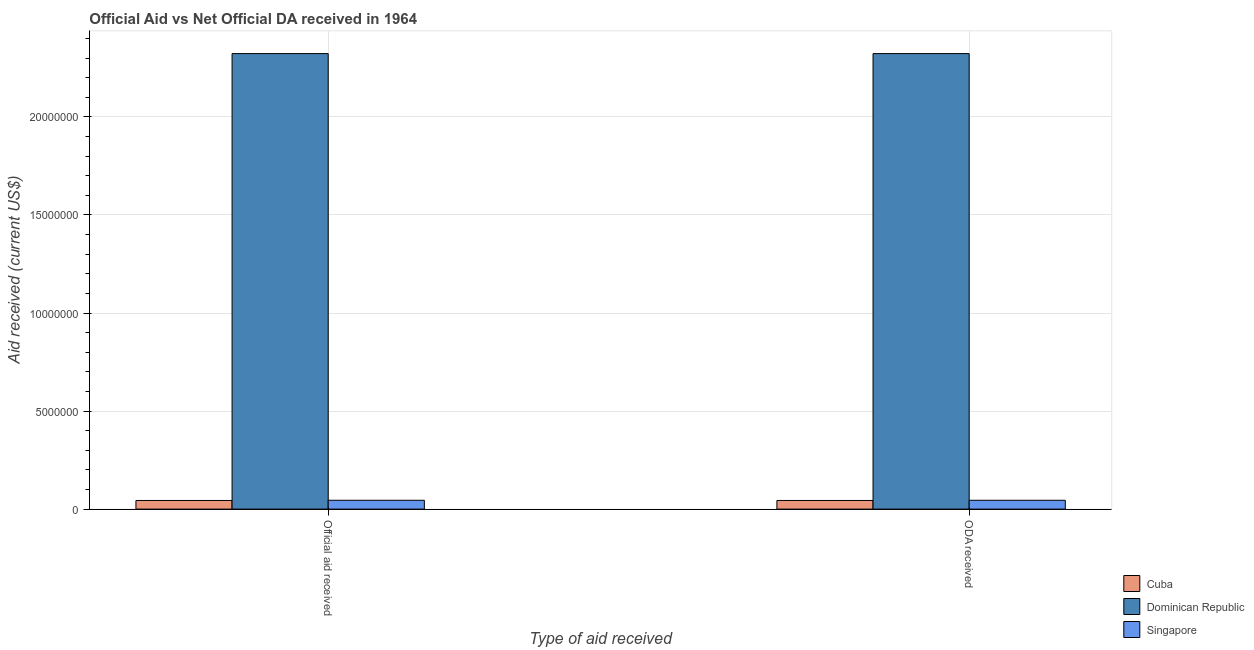How many groups of bars are there?
Make the answer very short. 2. Are the number of bars per tick equal to the number of legend labels?
Your response must be concise. Yes. Are the number of bars on each tick of the X-axis equal?
Ensure brevity in your answer.  Yes. How many bars are there on the 1st tick from the left?
Ensure brevity in your answer.  3. How many bars are there on the 1st tick from the right?
Your answer should be very brief. 3. What is the label of the 1st group of bars from the left?
Offer a very short reply. Official aid received. What is the oda received in Cuba?
Provide a succinct answer. 4.40e+05. Across all countries, what is the maximum official aid received?
Offer a terse response. 2.32e+07. Across all countries, what is the minimum oda received?
Provide a succinct answer. 4.40e+05. In which country was the oda received maximum?
Offer a very short reply. Dominican Republic. In which country was the oda received minimum?
Offer a terse response. Cuba. What is the total oda received in the graph?
Make the answer very short. 2.41e+07. What is the difference between the oda received in Cuba and that in Singapore?
Ensure brevity in your answer.  -10000. What is the difference between the official aid received in Singapore and the oda received in Dominican Republic?
Provide a succinct answer. -2.28e+07. What is the average oda received per country?
Provide a succinct answer. 8.04e+06. What is the difference between the oda received and official aid received in Cuba?
Provide a short and direct response. 0. What is the ratio of the official aid received in Cuba to that in Dominican Republic?
Your answer should be very brief. 0.02. In how many countries, is the oda received greater than the average oda received taken over all countries?
Ensure brevity in your answer.  1. What does the 3rd bar from the left in Official aid received represents?
Ensure brevity in your answer.  Singapore. What does the 2nd bar from the right in ODA received represents?
Ensure brevity in your answer.  Dominican Republic. How many bars are there?
Your answer should be compact. 6. How many countries are there in the graph?
Your response must be concise. 3. What is the difference between two consecutive major ticks on the Y-axis?
Your answer should be very brief. 5.00e+06. Are the values on the major ticks of Y-axis written in scientific E-notation?
Your answer should be very brief. No. Does the graph contain grids?
Your response must be concise. Yes. How are the legend labels stacked?
Provide a short and direct response. Vertical. What is the title of the graph?
Ensure brevity in your answer.  Official Aid vs Net Official DA received in 1964 . Does "Middle East & North Africa (developing only)" appear as one of the legend labels in the graph?
Your response must be concise. No. What is the label or title of the X-axis?
Offer a terse response. Type of aid received. What is the label or title of the Y-axis?
Your answer should be very brief. Aid received (current US$). What is the Aid received (current US$) in Dominican Republic in Official aid received?
Your answer should be compact. 2.32e+07. What is the Aid received (current US$) in Singapore in Official aid received?
Give a very brief answer. 4.50e+05. What is the Aid received (current US$) in Dominican Republic in ODA received?
Offer a terse response. 2.32e+07. Across all Type of aid received, what is the maximum Aid received (current US$) of Dominican Republic?
Ensure brevity in your answer.  2.32e+07. Across all Type of aid received, what is the maximum Aid received (current US$) in Singapore?
Offer a very short reply. 4.50e+05. Across all Type of aid received, what is the minimum Aid received (current US$) of Cuba?
Offer a terse response. 4.40e+05. Across all Type of aid received, what is the minimum Aid received (current US$) in Dominican Republic?
Give a very brief answer. 2.32e+07. Across all Type of aid received, what is the minimum Aid received (current US$) in Singapore?
Your answer should be very brief. 4.50e+05. What is the total Aid received (current US$) in Cuba in the graph?
Offer a very short reply. 8.80e+05. What is the total Aid received (current US$) of Dominican Republic in the graph?
Make the answer very short. 4.65e+07. What is the total Aid received (current US$) in Singapore in the graph?
Ensure brevity in your answer.  9.00e+05. What is the difference between the Aid received (current US$) of Singapore in Official aid received and that in ODA received?
Provide a succinct answer. 0. What is the difference between the Aid received (current US$) in Cuba in Official aid received and the Aid received (current US$) in Dominican Republic in ODA received?
Offer a terse response. -2.28e+07. What is the difference between the Aid received (current US$) in Cuba in Official aid received and the Aid received (current US$) in Singapore in ODA received?
Keep it short and to the point. -10000. What is the difference between the Aid received (current US$) in Dominican Republic in Official aid received and the Aid received (current US$) in Singapore in ODA received?
Your answer should be very brief. 2.28e+07. What is the average Aid received (current US$) of Cuba per Type of aid received?
Offer a terse response. 4.40e+05. What is the average Aid received (current US$) in Dominican Republic per Type of aid received?
Offer a very short reply. 2.32e+07. What is the difference between the Aid received (current US$) of Cuba and Aid received (current US$) of Dominican Republic in Official aid received?
Offer a very short reply. -2.28e+07. What is the difference between the Aid received (current US$) of Dominican Republic and Aid received (current US$) of Singapore in Official aid received?
Keep it short and to the point. 2.28e+07. What is the difference between the Aid received (current US$) of Cuba and Aid received (current US$) of Dominican Republic in ODA received?
Offer a very short reply. -2.28e+07. What is the difference between the Aid received (current US$) of Cuba and Aid received (current US$) of Singapore in ODA received?
Keep it short and to the point. -10000. What is the difference between the Aid received (current US$) of Dominican Republic and Aid received (current US$) of Singapore in ODA received?
Offer a very short reply. 2.28e+07. What is the ratio of the Aid received (current US$) in Cuba in Official aid received to that in ODA received?
Make the answer very short. 1. What is the ratio of the Aid received (current US$) of Singapore in Official aid received to that in ODA received?
Make the answer very short. 1. What is the difference between the highest and the second highest Aid received (current US$) in Cuba?
Your answer should be very brief. 0. What is the difference between the highest and the second highest Aid received (current US$) of Dominican Republic?
Make the answer very short. 0. What is the difference between the highest and the second highest Aid received (current US$) of Singapore?
Provide a succinct answer. 0. What is the difference between the highest and the lowest Aid received (current US$) in Dominican Republic?
Your answer should be very brief. 0. 